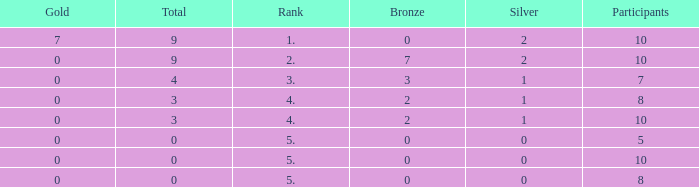What is the total rank for gold amounts smaller than 0? None. 